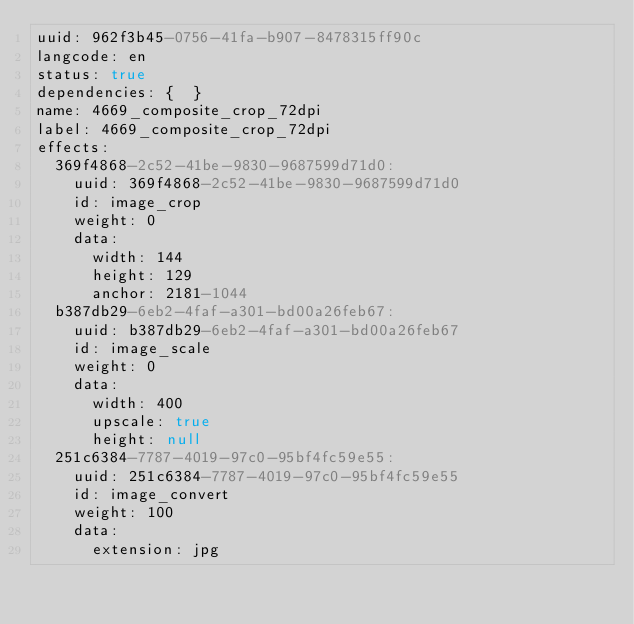Convert code to text. <code><loc_0><loc_0><loc_500><loc_500><_YAML_>uuid: 962f3b45-0756-41fa-b907-8478315ff90c
langcode: en
status: true
dependencies: {  }
name: 4669_composite_crop_72dpi
label: 4669_composite_crop_72dpi
effects:
  369f4868-2c52-41be-9830-9687599d71d0:
    uuid: 369f4868-2c52-41be-9830-9687599d71d0
    id: image_crop
    weight: 0
    data:
      width: 144
      height: 129
      anchor: 2181-1044
  b387db29-6eb2-4faf-a301-bd00a26feb67:
    uuid: b387db29-6eb2-4faf-a301-bd00a26feb67
    id: image_scale
    weight: 0
    data:
      width: 400
      upscale: true
      height: null
  251c6384-7787-4019-97c0-95bf4fc59e55:
    uuid: 251c6384-7787-4019-97c0-95bf4fc59e55
    id: image_convert
    weight: 100
    data:
      extension: jpg
</code> 